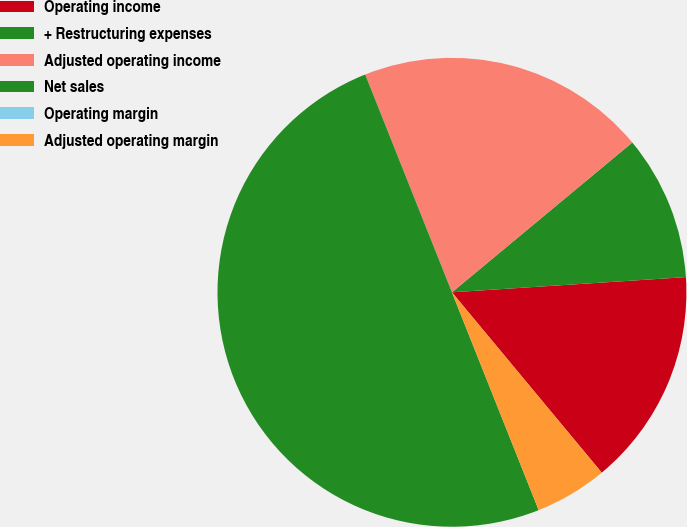Convert chart. <chart><loc_0><loc_0><loc_500><loc_500><pie_chart><fcel>Operating income<fcel>+ Restructuring expenses<fcel>Adjusted operating income<fcel>Net sales<fcel>Operating margin<fcel>Adjusted operating margin<nl><fcel>15.0%<fcel>10.0%<fcel>20.0%<fcel>50.0%<fcel>0.0%<fcel>5.0%<nl></chart> 